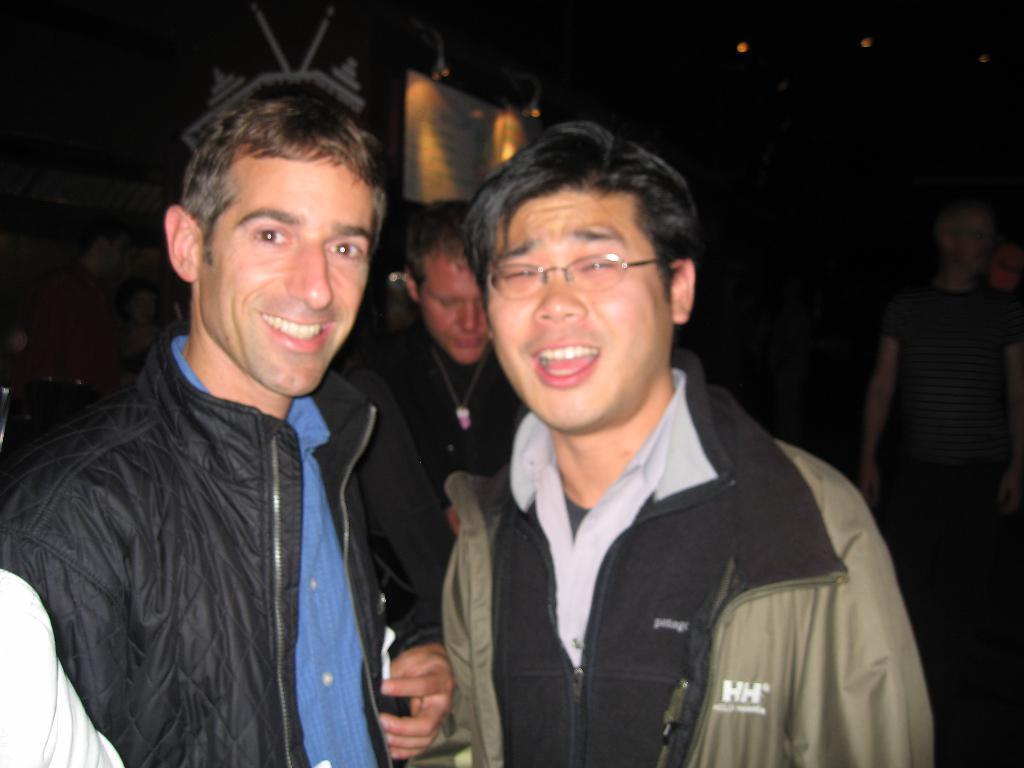Could you give a brief overview of what you see in this image? In this picture there are two boys wearing jacket, smiling and giving a pose into the camera. Behind there is a black background. 